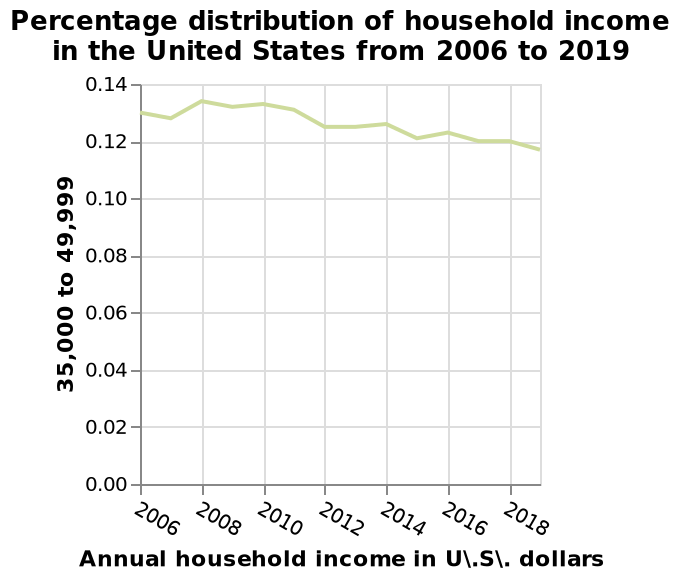<image>
What is the label on the x-axis of the line chart? The x-axis of the line chart is labeled "Annual household income in U.S. dollars." What is the trend in the annual household income from 2006 to 2018?  The trend in the annual household income from 2006 to 2018 is a decrease. Describe the following image in detail Here a line chart is named Percentage distribution of household income in the United States from 2006 to 2019. A linear scale of range 0.00 to 0.14 can be found along the y-axis, marked 35,000 to 49,999. There is a linear scale with a minimum of 2006 and a maximum of 2018 on the x-axis, labeled Annual household income in U\.S\. dollars. What is the impact of the falling annual household income on households? The falling annual household income may have various impacts on households, such as reduced savings, decreased purchasing power, and financial stress. 